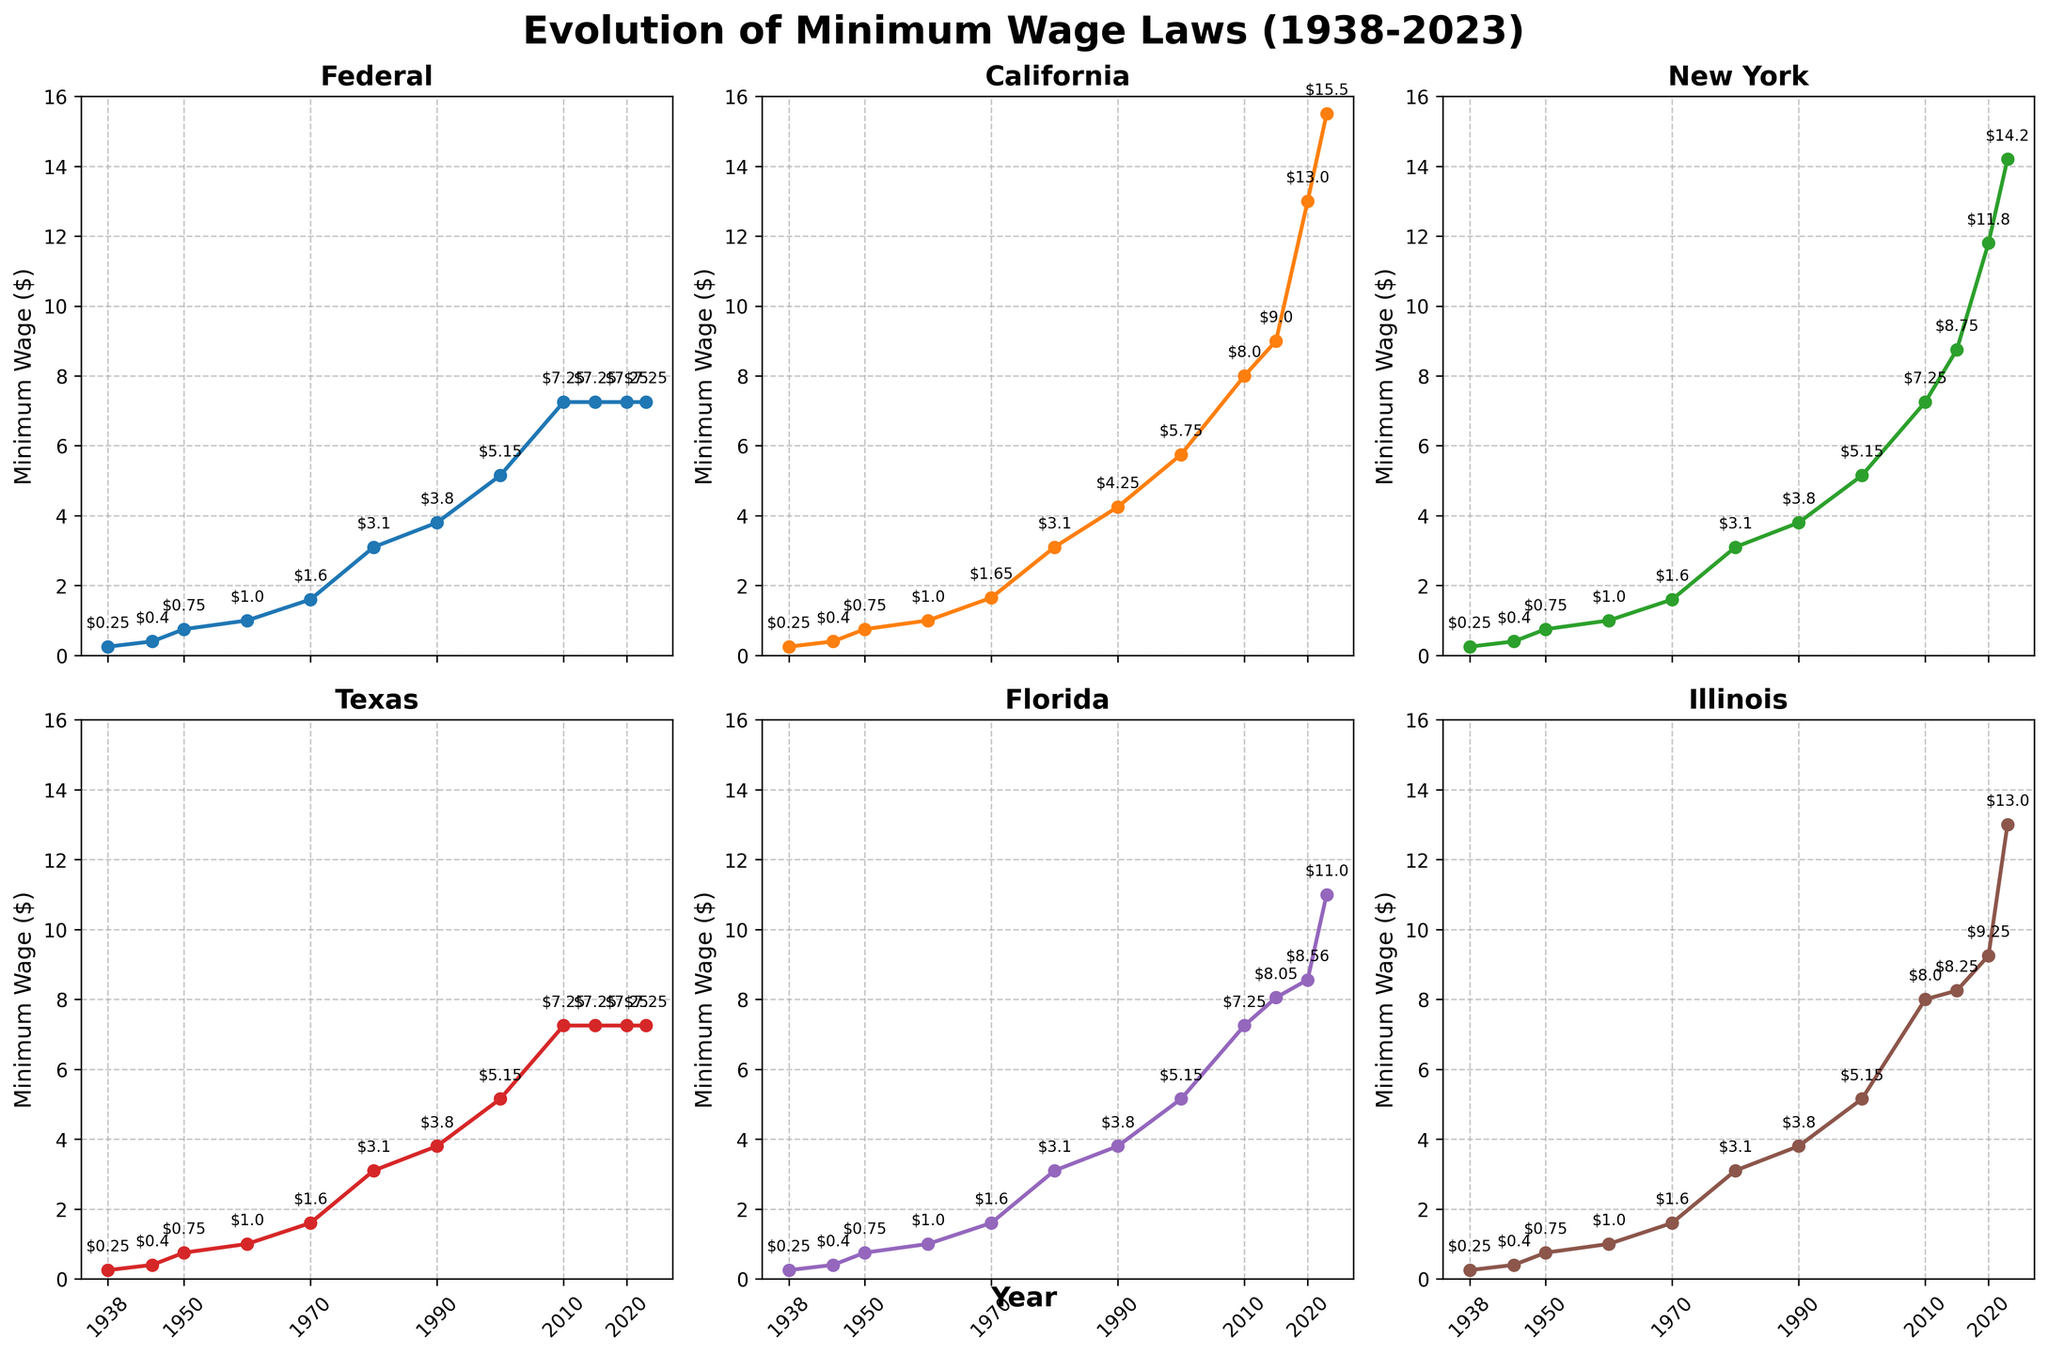Which state shows the highest minimum wage in 2023? The 2023 subplot for California shows a value of $15.50, which is the highest among all states in the figure.
Answer: California How much did the minimum wage in Florida increase from 2015 to 2023? In 2015, the minimum wage in Florida was $8.05, and it increased to $11.00 in 2023. The increase is $11.00 - $8.05 = $2.95.
Answer: $2.95 Which year did California first exceed the Federal minimum wage? Observing the California subplot, the minimum wage first exceeds the Federal level in 1990, with $4.25 for California compared to $3.80 for Federal.
Answer: 1990 By how much did the minimum wage of Illinois increase between 2010 and 2023? In 2010, the minimum wage in Illinois was $8.00. By 2023, it increased to $13.00. The increase is $13.00 - $8.00 = $5.00.
Answer: $5.00 Compare the 1980 minimum wage values for all states and determine which states had values higher than the federal level? In 1980, all states including the Federal had the same minimum wage value at $3.10.
Answer: None Which state had the least change in minimum wage between 2000 and 2023? The Texas subplot shows the minimum wage remained constant at $7.25 from 2000 to 2023.
Answer: Texas Calculate the average minimum wage across all states (including Federal) in 2015. The 2015 minimum wages are $7.25, $9.00, $8.75, $7.25, $8.05, and $8.25. The average is (7.25 + 9.00 + 8.75 + 7.25 + 8.05 + 8.25) / 6 = 48.55 / 6 = $8.09.
Answer: $8.09 Which state had the highest minimum wage increase from 2000 to 2023? California increased from $5.75 in 2000 to $15.50 in 2023, an increase of $15.50 - $5.75 = $9.75. By comparison, no other state had a higher increase.
Answer: California By what percentage did the minimum wage in New York increase from 2010 to 2023? The minimum wage in New York increased from $7.25 in 2010 to $14.20 in 2023. The percentage increase is ((14.20 - 7.25) / 7.25) * 100 ≈ 95.86%.
Answer: 95.86% In which year did Illinois and Florida have the same minimum wage, and what was the value? In 1980, both Illinois and Florida had the same minimum wage at $3.10.
Answer: 1980, $3.10 